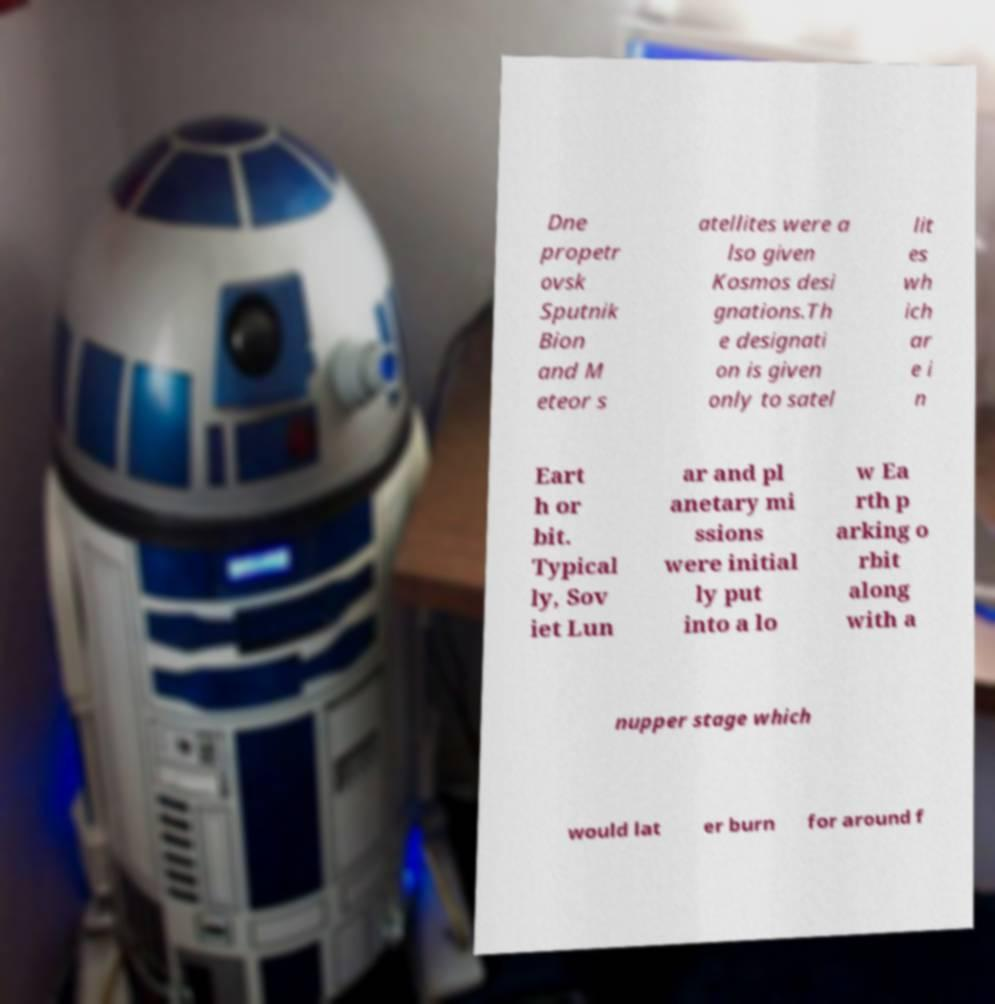Please read and relay the text visible in this image. What does it say? Dne propetr ovsk Sputnik Bion and M eteor s atellites were a lso given Kosmos desi gnations.Th e designati on is given only to satel lit es wh ich ar e i n Eart h or bit. Typical ly, Sov iet Lun ar and pl anetary mi ssions were initial ly put into a lo w Ea rth p arking o rbit along with a nupper stage which would lat er burn for around f 